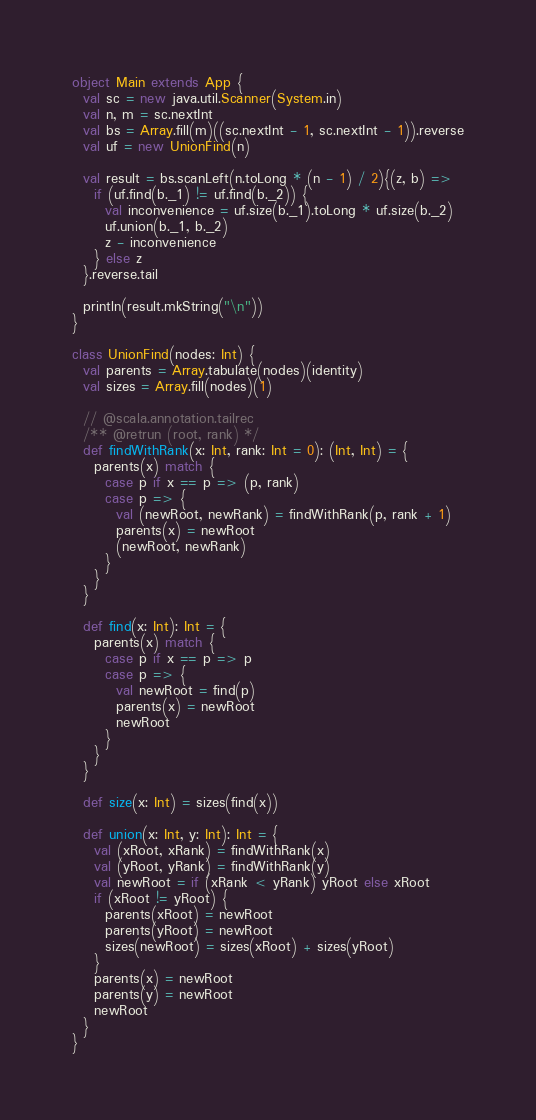Convert code to text. <code><loc_0><loc_0><loc_500><loc_500><_Scala_>object Main extends App {
  val sc = new java.util.Scanner(System.in)
  val n, m = sc.nextInt
  val bs = Array.fill(m)((sc.nextInt - 1, sc.nextInt - 1)).reverse
  val uf = new UnionFind(n)

  val result = bs.scanLeft(n.toLong * (n - 1) / 2){(z, b) =>
    if (uf.find(b._1) != uf.find(b._2)) {
      val inconvenience = uf.size(b._1).toLong * uf.size(b._2)
      uf.union(b._1, b._2)
      z - inconvenience
    } else z
  }.reverse.tail

  println(result.mkString("\n"))
}

class UnionFind(nodes: Int) {
  val parents = Array.tabulate(nodes)(identity)
  val sizes = Array.fill(nodes)(1)

  // @scala.annotation.tailrec
  /** @retrun (root, rank) */
  def findWithRank(x: Int, rank: Int = 0): (Int, Int) = {
    parents(x) match {
      case p if x == p => (p, rank)
      case p => {
        val (newRoot, newRank) = findWithRank(p, rank + 1)
        parents(x) = newRoot
        (newRoot, newRank)
      }
    }
  }

  def find(x: Int): Int = {
    parents(x) match {
      case p if x == p => p
      case p => {
        val newRoot = find(p)
        parents(x) = newRoot
        newRoot
      }
    }
  }

  def size(x: Int) = sizes(find(x))

  def union(x: Int, y: Int): Int = {
    val (xRoot, xRank) = findWithRank(x)
    val (yRoot, yRank) = findWithRank(y)
    val newRoot = if (xRank < yRank) yRoot else xRoot
    if (xRoot != yRoot) {
      parents(xRoot) = newRoot
      parents(yRoot) = newRoot
      sizes(newRoot) = sizes(xRoot) + sizes(yRoot)
    }
    parents(x) = newRoot
    parents(y) = newRoot
    newRoot
  }
}</code> 